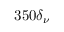Convert formula to latex. <formula><loc_0><loc_0><loc_500><loc_500>3 5 0 \delta _ { \nu }</formula> 